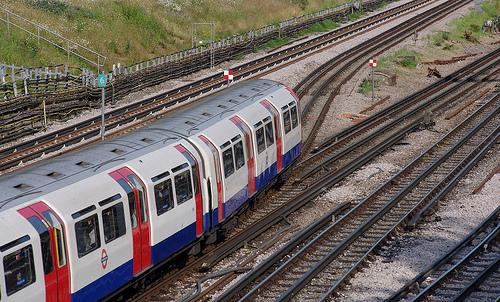Provide a brief description of the primary object in the image. A train with red, white, and blue colors is situated on tracks, surrounded by various signs and objects. In a descriptive phrase, express the main focus of the image. A vividly-colored train stationed on tracks amidst a collection of diverse signs and elements. Enumerate some elements found around the train tracks in the image. Gravel, a green sign, a blue sign, a red and white sign, and a grey fence are present near the tracks. Describe any details you can see regarding the signs near the train tracks. There are blue and green signs attached to metal poles and red and white signs standing by the tracks. What catches your eye in the image related to the train and its surroundings? The striking colors of the train and the presence of multiple, differently-colored signs around the tracks stand out. In a single sentence, summarize the overall scene captured in the image. The image displays a colorful train on tracks, accompanied by various signs and items in the vicinity. Comment on the colors and markings of the train pictured. The train exhibits a vibrant combination of red, white, and blue colors with notable red doors. Mention any notable features you observe about the train in the image. The train has red doors, a blue stripe at the bottom, and several windows along its side. Tell us about the setting of the image, focusing on the train and nearby objects. The scene takes place at a railway, with a multicolored train on the tracks surrounded by an assortment of signs and features. Discuss the appearance of the train's doors and windows in the image. The train has red doors and windows along its side, some of which appear to be ajar or slightly open. 